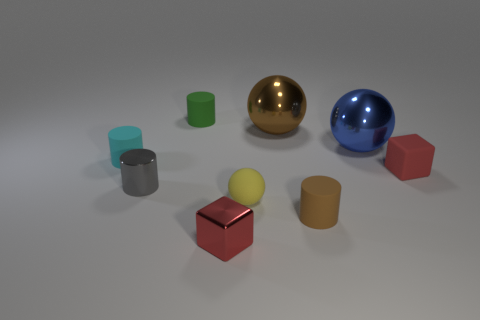There is a gray thing that is the same material as the blue ball; what is its size?
Provide a short and direct response. Small. Are the tiny gray object in front of the large blue metallic sphere and the brown thing on the right side of the large brown ball made of the same material?
Give a very brief answer. No. How many cylinders are blue things or metallic objects?
Make the answer very short. 1. What number of blue shiny spheres are in front of the sphere in front of the red thing on the right side of the small red shiny block?
Provide a succinct answer. 0. What is the material of the other red thing that is the same shape as the tiny red metallic object?
Ensure brevity in your answer.  Rubber. The rubber cylinder that is in front of the yellow thing is what color?
Give a very brief answer. Brown. Do the small ball and the large ball that is behind the big blue thing have the same material?
Offer a terse response. No. What is the cyan object made of?
Your answer should be very brief. Rubber. There is a large blue thing that is the same material as the tiny gray thing; what is its shape?
Offer a terse response. Sphere. What number of other things are there of the same shape as the large blue thing?
Provide a short and direct response. 2. 